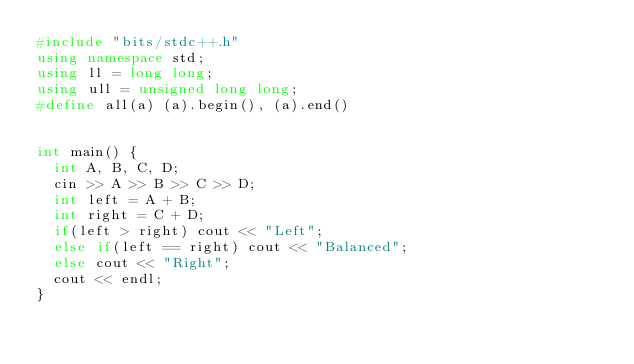<code> <loc_0><loc_0><loc_500><loc_500><_C++_>#include "bits/stdc++.h"
using namespace std;
using ll = long long;
using ull = unsigned long long;
#define all(a) (a).begin(), (a).end()
 
 
int main() {
  int A, B, C, D;
  cin >> A >> B >> C >> D;
  int left = A + B;
  int right = C + D;
  if(left > right) cout << "Left";
  else if(left == right) cout << "Balanced";
  else cout << "Right";
  cout << endl;
}</code> 